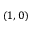Convert formula to latex. <formula><loc_0><loc_0><loc_500><loc_500>( 1 , 0 )</formula> 